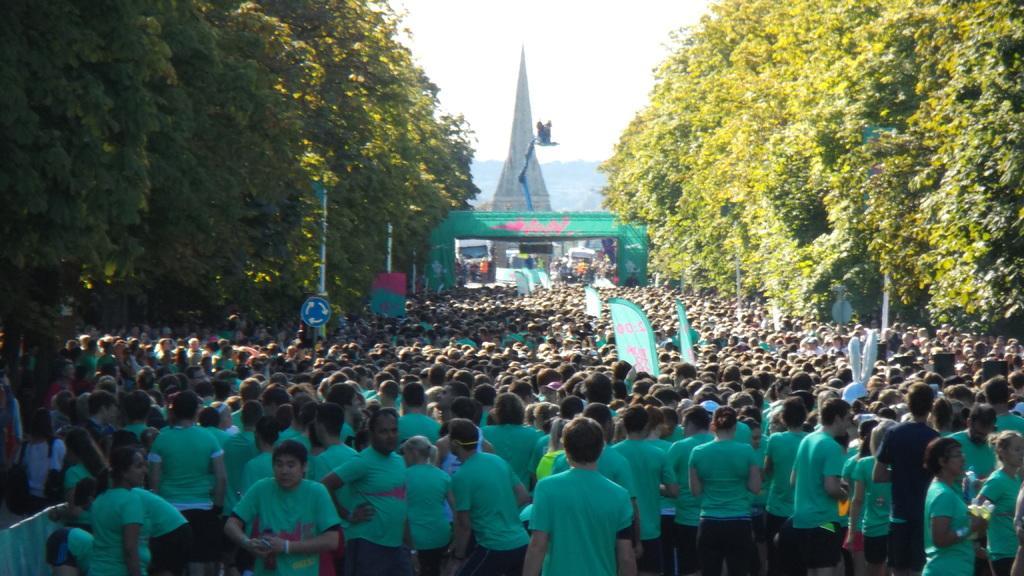Describe this image in one or two sentences. In the image there are many people standing on the road, they all wore sea green t-shirt, on either side of it there are trees, in the back it seems to be a tower and above its sky. 